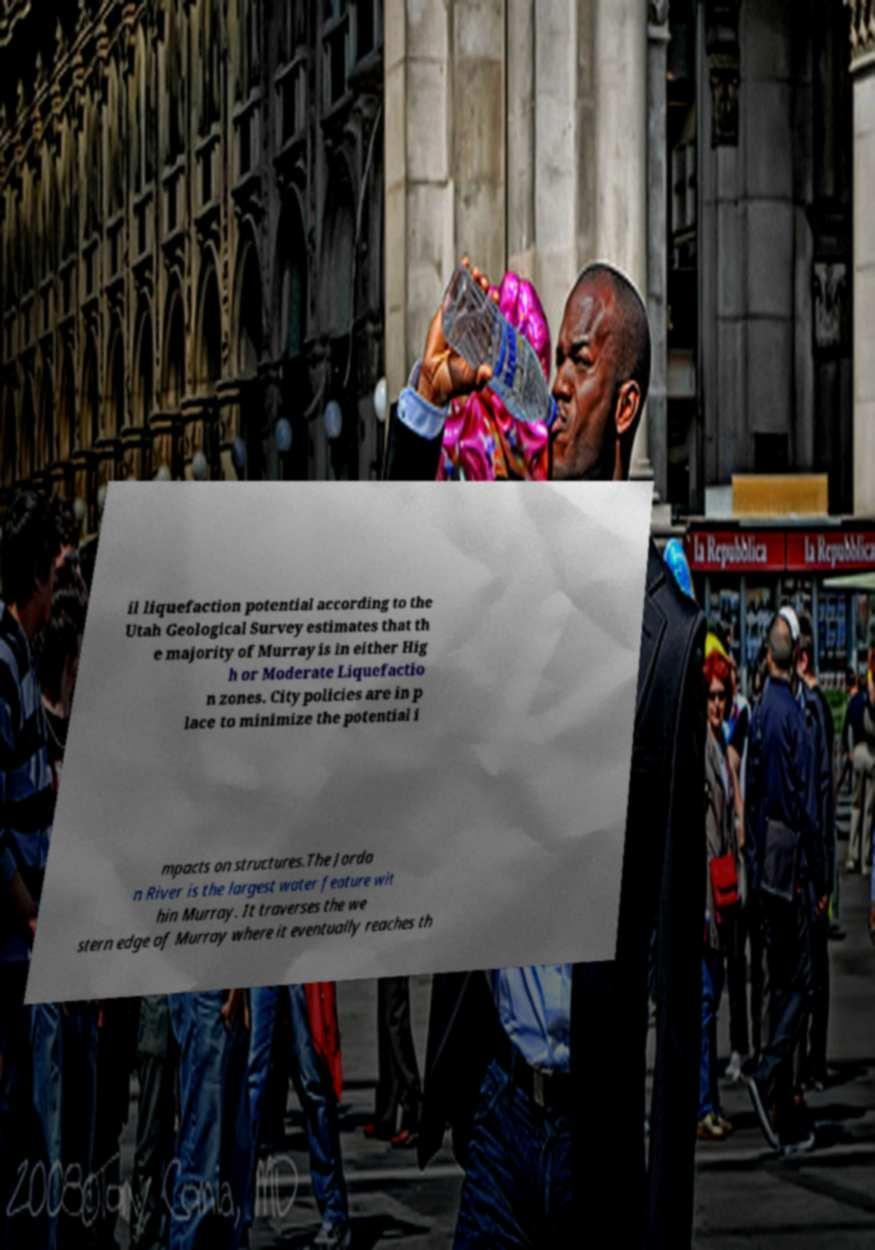Please read and relay the text visible in this image. What does it say? il liquefaction potential according to the Utah Geological Survey estimates that th e majority of Murray is in either Hig h or Moderate Liquefactio n zones. City policies are in p lace to minimize the potential i mpacts on structures.The Jorda n River is the largest water feature wit hin Murray. It traverses the we stern edge of Murray where it eventually reaches th 